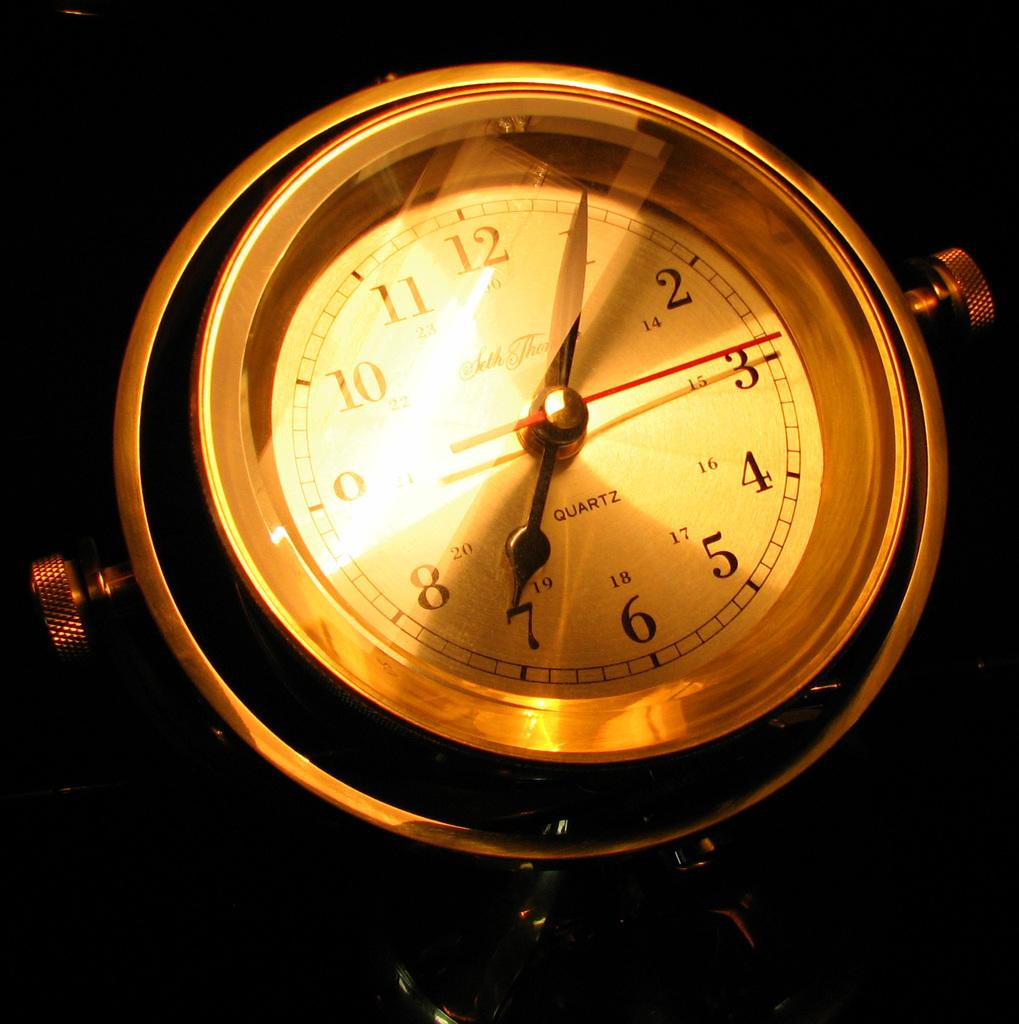<image>
Summarize the visual content of the image. A golden clock with Quartz written on it is showing the time 7:05. 